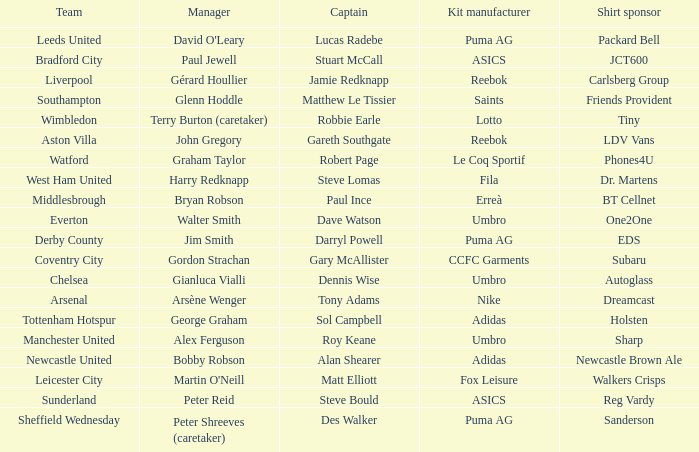Which captain is managed by gianluca vialli? Dennis Wise. 